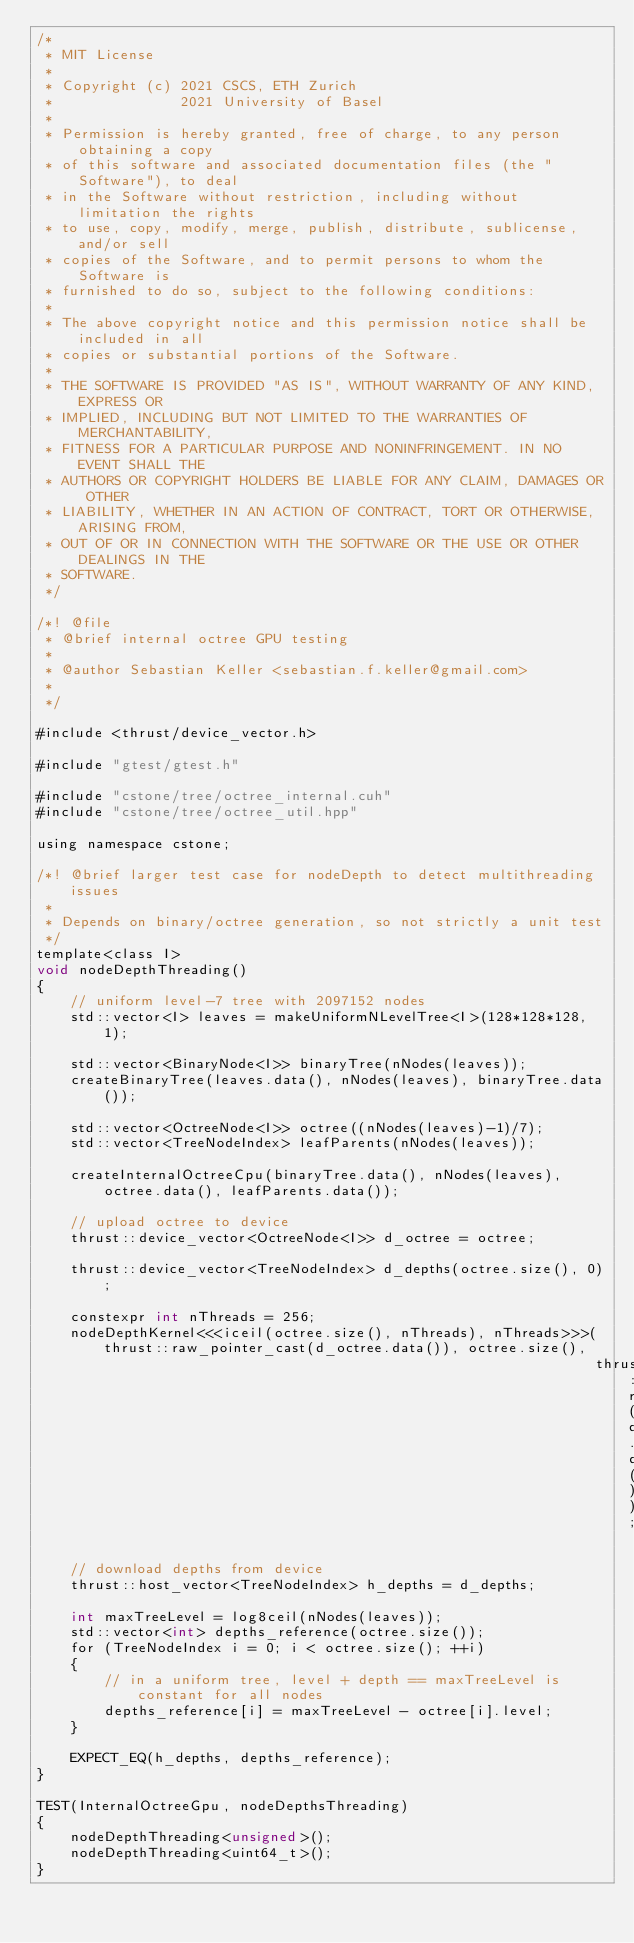Convert code to text. <code><loc_0><loc_0><loc_500><loc_500><_Cuda_>/*
 * MIT License
 *
 * Copyright (c) 2021 CSCS, ETH Zurich
 *               2021 University of Basel
 *
 * Permission is hereby granted, free of charge, to any person obtaining a copy
 * of this software and associated documentation files (the "Software"), to deal
 * in the Software without restriction, including without limitation the rights
 * to use, copy, modify, merge, publish, distribute, sublicense, and/or sell
 * copies of the Software, and to permit persons to whom the Software is
 * furnished to do so, subject to the following conditions:
 *
 * The above copyright notice and this permission notice shall be included in all
 * copies or substantial portions of the Software.
 *
 * THE SOFTWARE IS PROVIDED "AS IS", WITHOUT WARRANTY OF ANY KIND, EXPRESS OR
 * IMPLIED, INCLUDING BUT NOT LIMITED TO THE WARRANTIES OF MERCHANTABILITY,
 * FITNESS FOR A PARTICULAR PURPOSE AND NONINFRINGEMENT. IN NO EVENT SHALL THE
 * AUTHORS OR COPYRIGHT HOLDERS BE LIABLE FOR ANY CLAIM, DAMAGES OR OTHER
 * LIABILITY, WHETHER IN AN ACTION OF CONTRACT, TORT OR OTHERWISE, ARISING FROM,
 * OUT OF OR IN CONNECTION WITH THE SOFTWARE OR THE USE OR OTHER DEALINGS IN THE
 * SOFTWARE.
 */

/*! @file
 * @brief internal octree GPU testing
 *
 * @author Sebastian Keller <sebastian.f.keller@gmail.com>
 *
 */

#include <thrust/device_vector.h>

#include "gtest/gtest.h"

#include "cstone/tree/octree_internal.cuh"
#include "cstone/tree/octree_util.hpp"

using namespace cstone;

/*! @brief larger test case for nodeDepth to detect multithreading issues
 *
 * Depends on binary/octree generation, so not strictly a unit test
 */
template<class I>
void nodeDepthThreading()
{
    // uniform level-7 tree with 2097152 nodes
    std::vector<I> leaves = makeUniformNLevelTree<I>(128*128*128, 1);

    std::vector<BinaryNode<I>> binaryTree(nNodes(leaves));
    createBinaryTree(leaves.data(), nNodes(leaves), binaryTree.data());

    std::vector<OctreeNode<I>> octree((nNodes(leaves)-1)/7);
    std::vector<TreeNodeIndex> leafParents(nNodes(leaves));

    createInternalOctreeCpu(binaryTree.data(), nNodes(leaves), octree.data(), leafParents.data());

    // upload octree to device
    thrust::device_vector<OctreeNode<I>> d_octree = octree;

    thrust::device_vector<TreeNodeIndex> d_depths(octree.size(), 0);

    constexpr int nThreads = 256;
    nodeDepthKernel<<<iceil(octree.size(), nThreads), nThreads>>>(thrust::raw_pointer_cast(d_octree.data()), octree.size(),
                                                                  thrust::raw_pointer_cast(d_depths.data()));

    // download depths from device
    thrust::host_vector<TreeNodeIndex> h_depths = d_depths;

    int maxTreeLevel = log8ceil(nNodes(leaves));
    std::vector<int> depths_reference(octree.size());
    for (TreeNodeIndex i = 0; i < octree.size(); ++i)
    {
        // in a uniform tree, level + depth == maxTreeLevel is constant for all nodes
        depths_reference[i] = maxTreeLevel - octree[i].level;
    }

    EXPECT_EQ(h_depths, depths_reference);
}

TEST(InternalOctreeGpu, nodeDepthsThreading)
{
    nodeDepthThreading<unsigned>();
    nodeDepthThreading<uint64_t>();
}</code> 